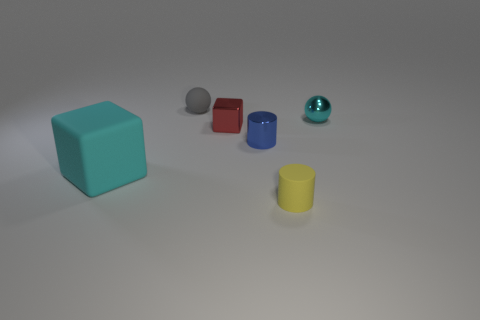Add 3 red cubes. How many objects exist? 9 Subtract all spheres. How many objects are left? 4 Subtract 0 purple blocks. How many objects are left? 6 Subtract all brown metallic things. Subtract all large matte cubes. How many objects are left? 5 Add 6 tiny blue metal objects. How many tiny blue metal objects are left? 7 Add 5 big red rubber balls. How many big red rubber balls exist? 5 